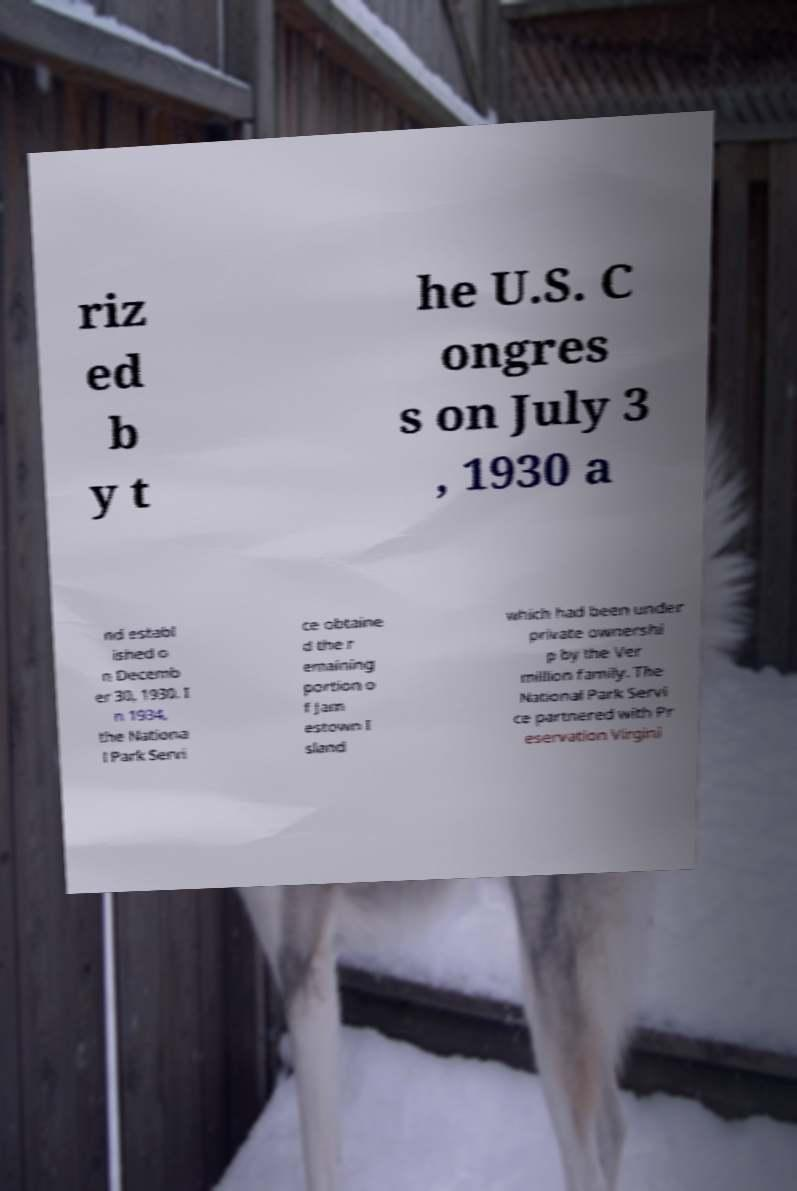Can you accurately transcribe the text from the provided image for me? riz ed b y t he U.S. C ongres s on July 3 , 1930 a nd establ ished o n Decemb er 30, 1930. I n 1934, the Nationa l Park Servi ce obtaine d the r emaining portion o f Jam estown I sland which had been under private ownershi p by the Ver million family. The National Park Servi ce partnered with Pr eservation Virgini 